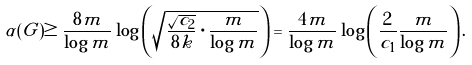<formula> <loc_0><loc_0><loc_500><loc_500>\alpha ( G ) \geq \frac { 8 m } { \log m } \log \left ( \sqrt { \frac { \sqrt { c _ { 2 } } } { 8 k } \cdot \frac { m } { \log m } } \right ) = \frac { 4 m } { \log m } \log \left ( \frac { 2 } { c _ { 1 } } \frac { m } { \log m } \right ) .</formula> 